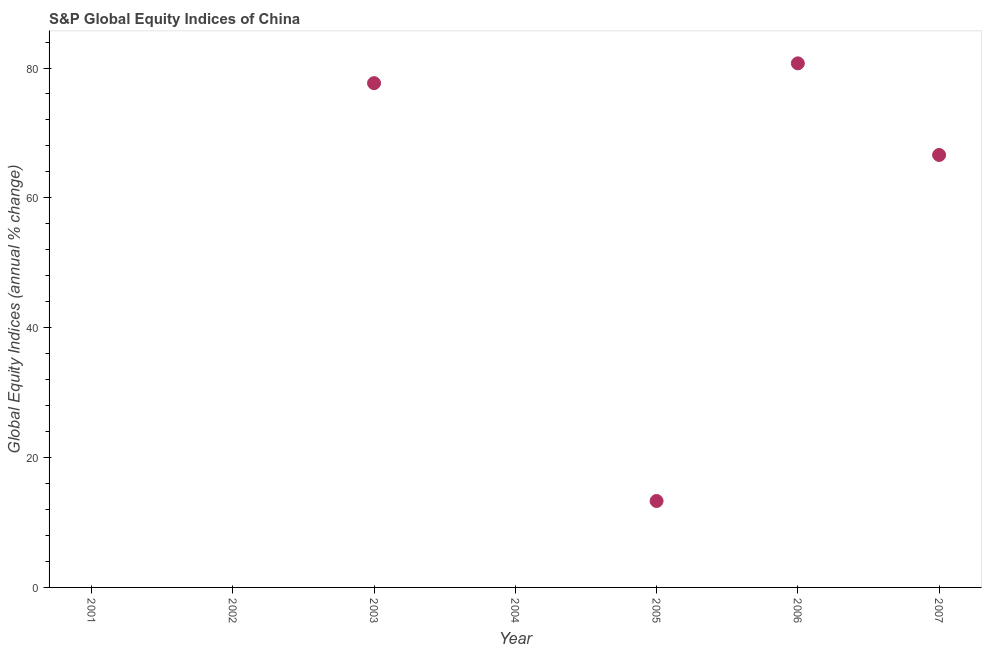What is the s&p global equity indices in 2006?
Ensure brevity in your answer.  80.72. Across all years, what is the maximum s&p global equity indices?
Your answer should be compact. 80.72. What is the sum of the s&p global equity indices?
Make the answer very short. 238.31. What is the difference between the s&p global equity indices in 2003 and 2007?
Offer a terse response. 11.06. What is the average s&p global equity indices per year?
Provide a short and direct response. 34.04. What is the median s&p global equity indices?
Keep it short and to the point. 13.31. Is the s&p global equity indices in 2006 less than that in 2007?
Keep it short and to the point. No. Is the difference between the s&p global equity indices in 2005 and 2006 greater than the difference between any two years?
Offer a very short reply. No. What is the difference between the highest and the second highest s&p global equity indices?
Provide a short and direct response. 3.05. What is the difference between the highest and the lowest s&p global equity indices?
Make the answer very short. 80.72. Does the s&p global equity indices monotonically increase over the years?
Offer a very short reply. No. Does the graph contain any zero values?
Keep it short and to the point. Yes. What is the title of the graph?
Provide a succinct answer. S&P Global Equity Indices of China. What is the label or title of the Y-axis?
Your answer should be compact. Global Equity Indices (annual % change). What is the Global Equity Indices (annual % change) in 2001?
Ensure brevity in your answer.  0. What is the Global Equity Indices (annual % change) in 2003?
Ensure brevity in your answer.  77.67. What is the Global Equity Indices (annual % change) in 2004?
Ensure brevity in your answer.  0. What is the Global Equity Indices (annual % change) in 2005?
Give a very brief answer. 13.31. What is the Global Equity Indices (annual % change) in 2006?
Your answer should be compact. 80.72. What is the Global Equity Indices (annual % change) in 2007?
Your response must be concise. 66.61. What is the difference between the Global Equity Indices (annual % change) in 2003 and 2005?
Offer a very short reply. 64.36. What is the difference between the Global Equity Indices (annual % change) in 2003 and 2006?
Your response must be concise. -3.05. What is the difference between the Global Equity Indices (annual % change) in 2003 and 2007?
Your answer should be compact. 11.06. What is the difference between the Global Equity Indices (annual % change) in 2005 and 2006?
Your answer should be very brief. -67.41. What is the difference between the Global Equity Indices (annual % change) in 2005 and 2007?
Make the answer very short. -53.3. What is the difference between the Global Equity Indices (annual % change) in 2006 and 2007?
Your answer should be compact. 14.11. What is the ratio of the Global Equity Indices (annual % change) in 2003 to that in 2005?
Offer a very short reply. 5.83. What is the ratio of the Global Equity Indices (annual % change) in 2003 to that in 2007?
Provide a succinct answer. 1.17. What is the ratio of the Global Equity Indices (annual % change) in 2005 to that in 2006?
Give a very brief answer. 0.17. What is the ratio of the Global Equity Indices (annual % change) in 2005 to that in 2007?
Give a very brief answer. 0.2. What is the ratio of the Global Equity Indices (annual % change) in 2006 to that in 2007?
Make the answer very short. 1.21. 